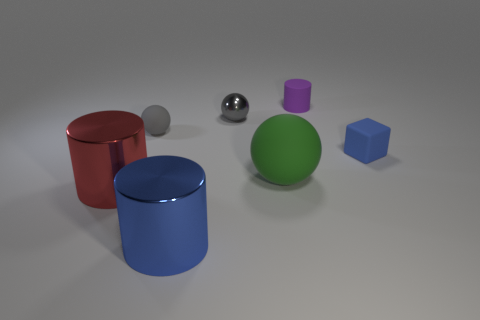How many objects are left of the green matte object and behind the red metallic object?
Provide a short and direct response. 2. Is there anything else that has the same shape as the tiny blue object?
Provide a short and direct response. No. Is the color of the matte block the same as the big thing that is in front of the large red object?
Ensure brevity in your answer.  Yes. There is a tiny thing that is in front of the small gray matte object; what is its shape?
Your answer should be compact. Cube. What number of other objects are the same material as the tiny purple object?
Your response must be concise. 3. What is the tiny cube made of?
Give a very brief answer. Rubber. What number of tiny objects are either green objects or purple rubber objects?
Make the answer very short. 1. There is a big blue metal thing; what number of large matte things are on the left side of it?
Offer a terse response. 0. Are there any small shiny things that have the same color as the small matte sphere?
Your response must be concise. Yes. There is a gray rubber thing that is the same size as the purple cylinder; what shape is it?
Provide a short and direct response. Sphere. 